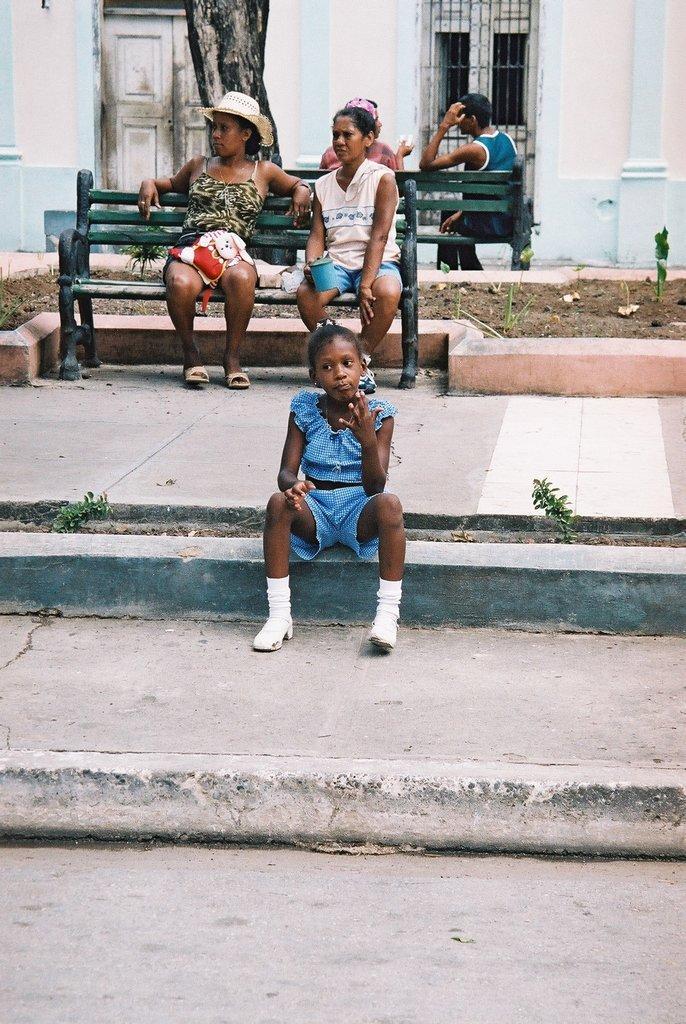Could you give a brief overview of what you see in this image? In the center of the image there is a girl sitting on the ground. In the background there are persons sitting on the benches. In the background there is a tree, door, window and wall. 